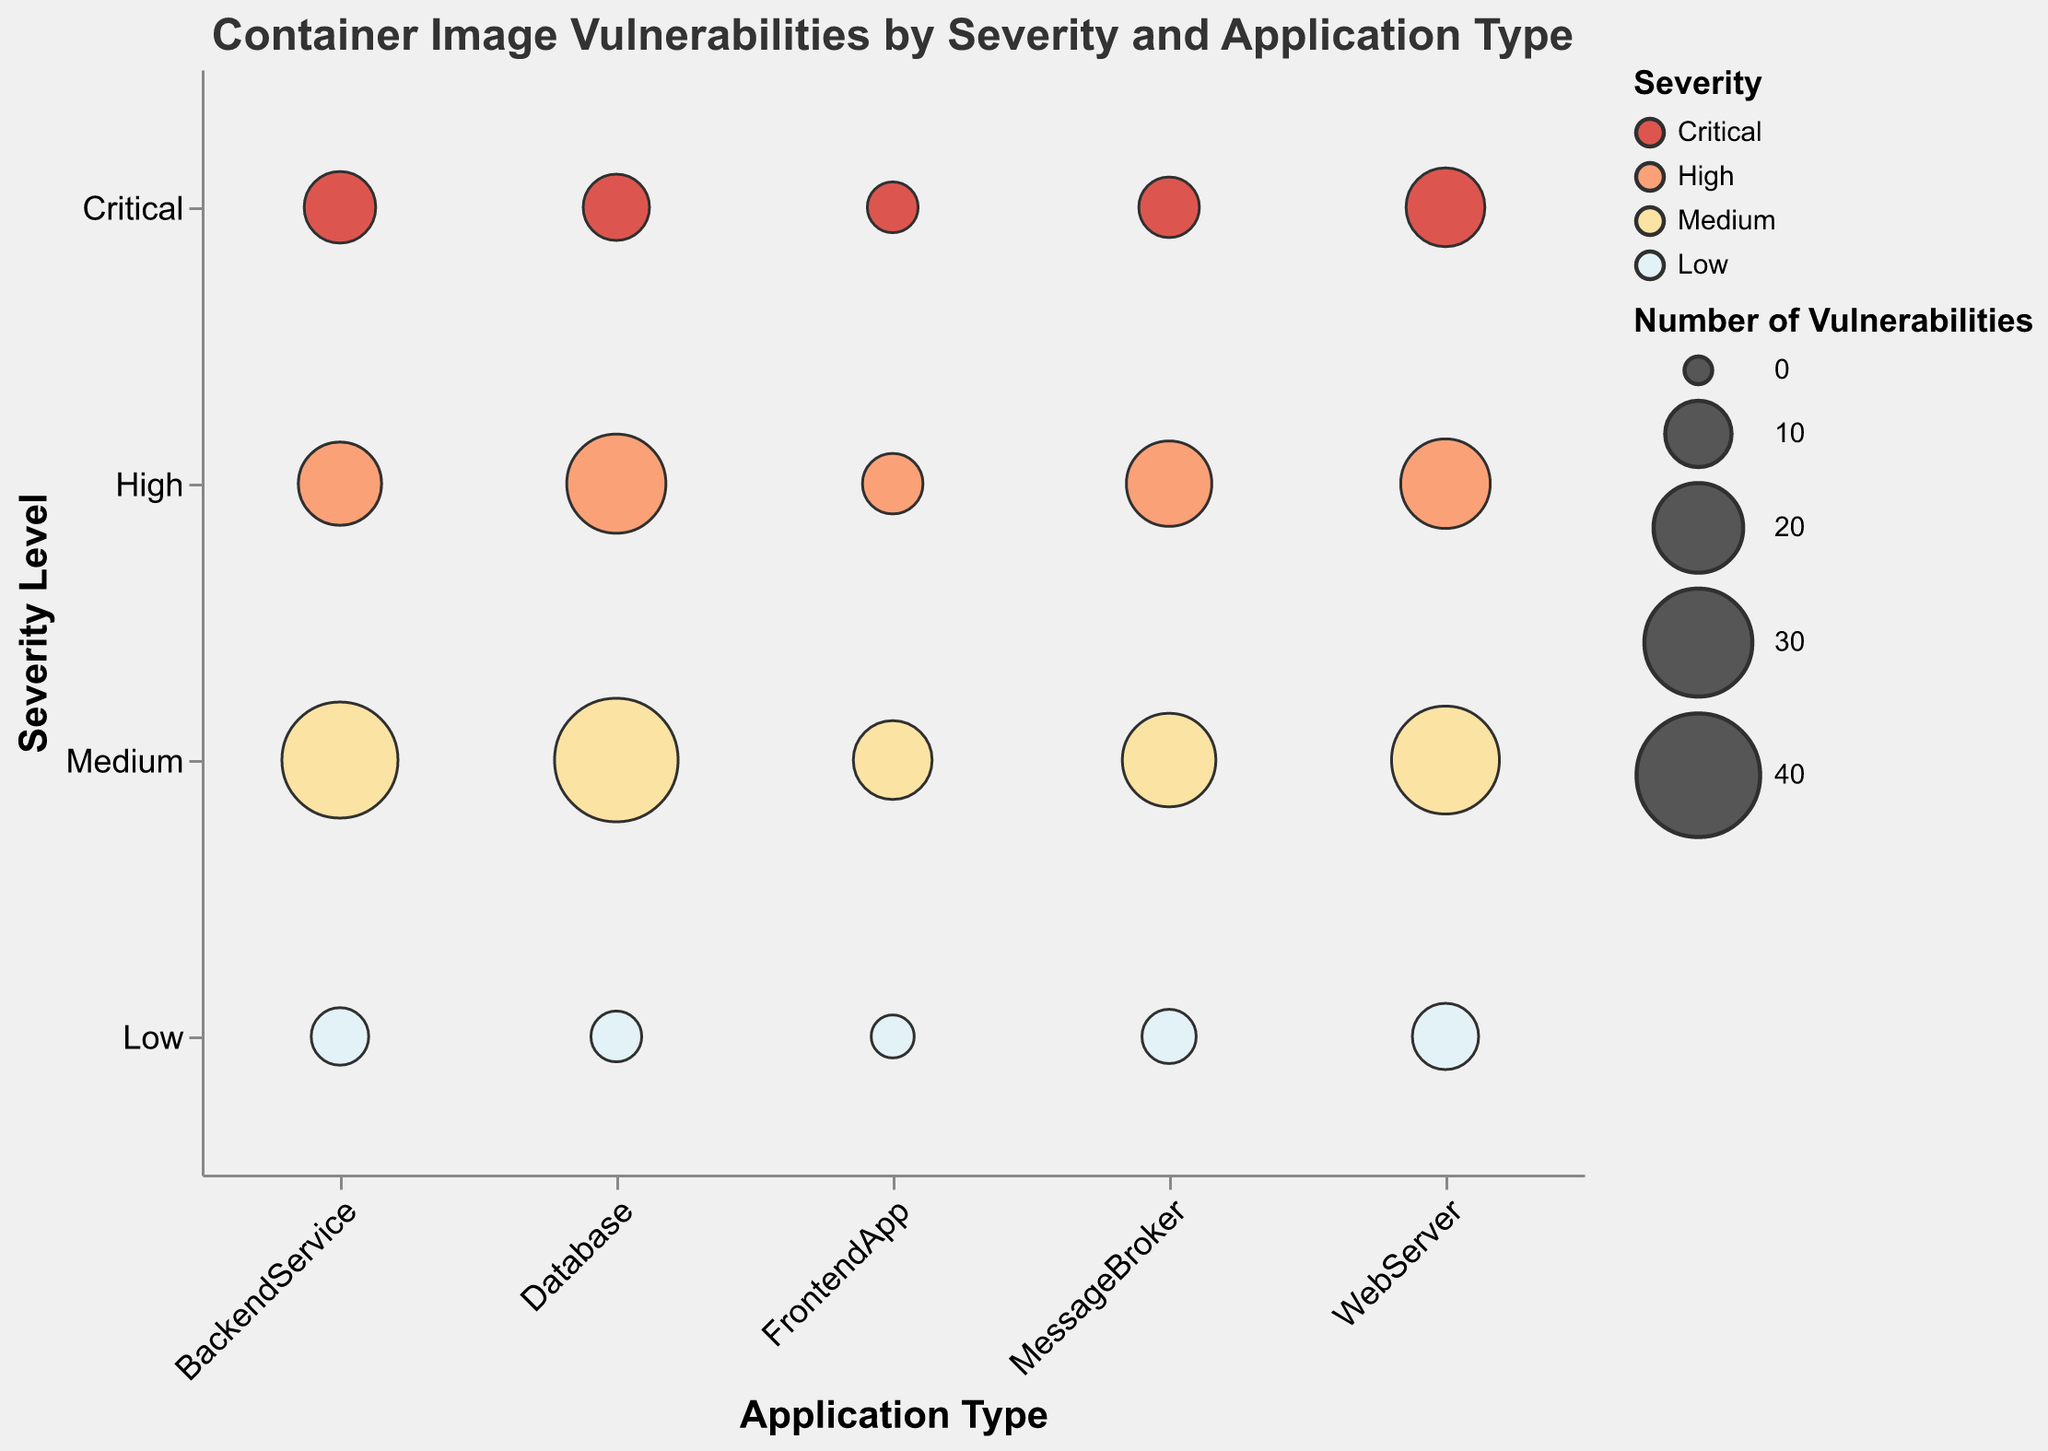What is the title of the chart? The title is displayed at the top of the chart in a larger font size than the axis labels.
Answer: Container Image Vulnerabilities by Severity and Application Type How many vulnerabilities does the `nginx:latest` image have at `High` severity? Locate the `WebServer` application type, find the bubble at the `High` severity level, and check the tooltip.
Answer: 20 Which application type has the highest number of `Critical` vulnerabilities? Compare the sizes of bubbles located at the `Critical` severity level for each application type and identify the largest one.
Answer: WebServer Is the number of `Medium` severity vulnerabilities higher for `Database` or `BackendService`? Compare the sizes of the bubbles in the `Medium` severity row under `Database` and `BackendService`.
Answer: BackendService How many total vulnerabilities are there for the `MessageBroker` application type? (Hint: Sum all severity levels) Add the number of vulnerabilities for `Critical`, `High`, `Medium`, and `Low` severities for `MessageBroker`. 8 + 18 + 22 + 6 = 54
Answer: 54 Which application type has the fewest `Low` severity vulnerabilities? Identify the bubble with the smallest size located at the `Low` severity level and the application type associated with it.
Answer: FrontendApp What color represents `High` severity vulnerabilities in the chart? Refer to the color legend on the chart and find the color associated with `High` severity.
Answer: Orange Are there more `Low` severity vulnerabilities in `react:16` or `rabbitmq:management`? Compare the bubble sizes for `Low` severity under the application types `FrontendApp` and `MessageBroker`.
Answer: rabbitmq:management What is the image with the most `High` severity vulnerabilities? Find the application type with the largest bubble in the `High` severity row and note the image from the tooltip.
Answer: postgres:alpine How does the number of `Medium` severity vulnerabilities in `BackendService` compare to `FrontendApp`? Find and compare the bubble sizes for `Medium` severity in `BackendService` and `FrontendApp`.
Answer: BackendService has more 